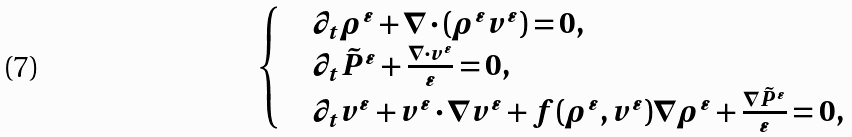Convert formula to latex. <formula><loc_0><loc_0><loc_500><loc_500>\begin{cases} & \partial _ { t } \rho ^ { \varepsilon } + \nabla \cdot ( \rho ^ { \varepsilon } v ^ { \varepsilon } ) = 0 , \\ & \partial _ { t } \tilde { P } ^ { \varepsilon } + \frac { \nabla \cdot v ^ { \varepsilon } } { \varepsilon } = 0 , \\ & \partial _ { t } { v ^ { \varepsilon } } + { v ^ { \varepsilon } } \cdot \nabla { v ^ { \varepsilon } } + f ( \rho ^ { \varepsilon } , v ^ { \varepsilon } ) \nabla \rho ^ { \varepsilon } + \frac { \nabla { \tilde { P } ^ { \varepsilon } } } { \varepsilon } = 0 , \end{cases}</formula> 